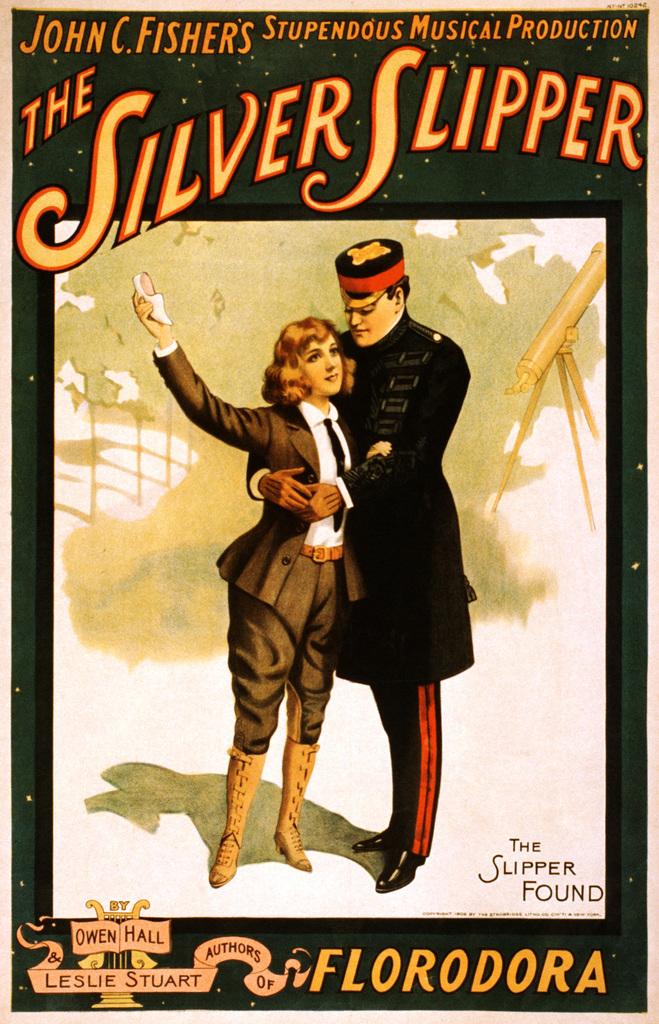What is the title of this musical?
Provide a succinct answer. The silver slipper. Who is the screenwriter at the top left?
Your response must be concise. John c. fishers. 